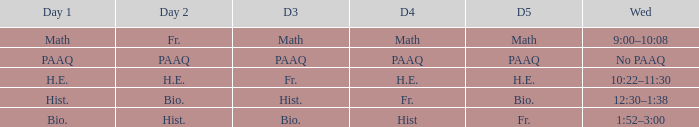What is the day 1 when day 5 is math? Math. 